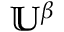<formula> <loc_0><loc_0><loc_500><loc_500>\mathbb { U } ^ { \beta }</formula> 